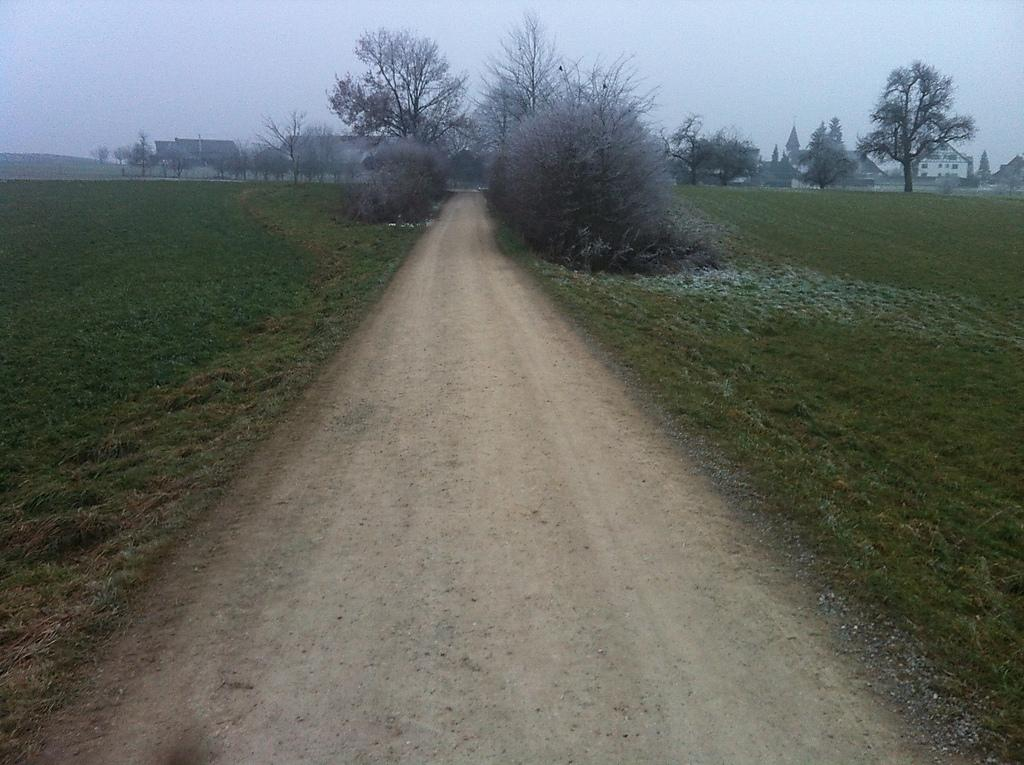What type of vegetation can be seen in the image? There is grass, plants, and trees in the image. Are there any man-made structures visible in the image? Yes, there are buildings in the image. What part of the natural environment is visible in the image? The sky is visible in the image. What might be the location of the image, based on the vegetation and structures present? The image may have been taken near a farm, given the presence of grass, plants, and trees, as well as buildings. What type of cookware is being used in the battle depicted in the image? There is no battle or cookware present in the image; it features grass, plants, trees, buildings, and the sky. 